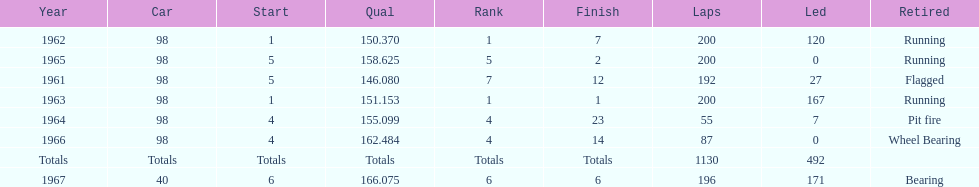How many total laps have been driven in the indy 500? 1130. 